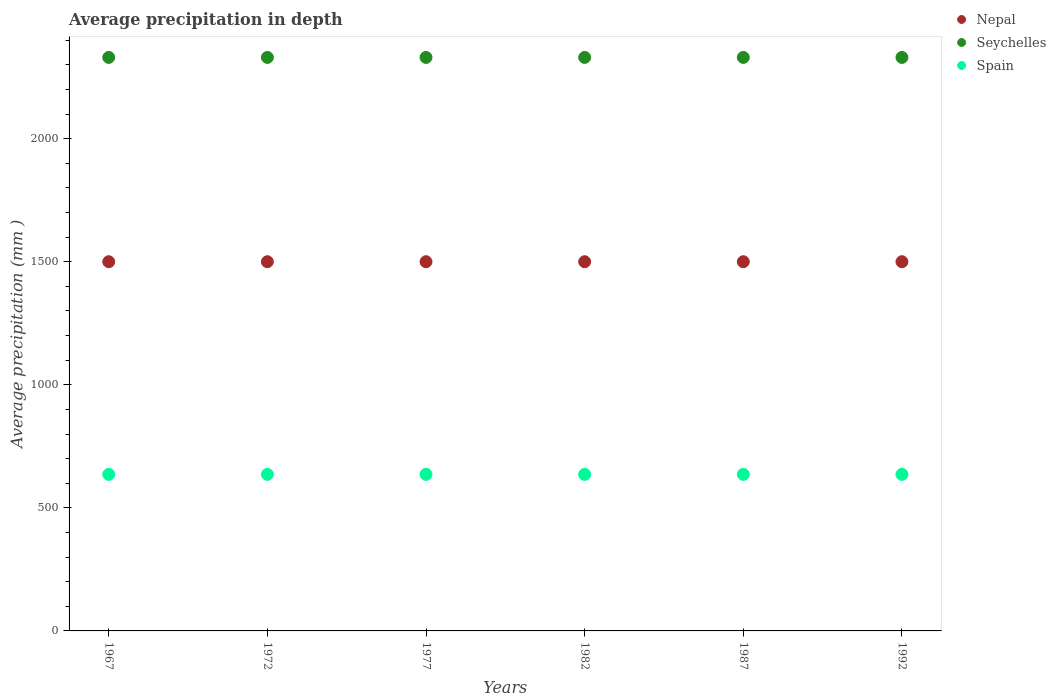How many different coloured dotlines are there?
Provide a succinct answer. 3. Is the number of dotlines equal to the number of legend labels?
Offer a very short reply. Yes. What is the average precipitation in Spain in 1972?
Make the answer very short. 636. Across all years, what is the maximum average precipitation in Spain?
Your answer should be very brief. 636. Across all years, what is the minimum average precipitation in Nepal?
Offer a terse response. 1500. In which year was the average precipitation in Spain maximum?
Make the answer very short. 1967. In which year was the average precipitation in Seychelles minimum?
Keep it short and to the point. 1967. What is the total average precipitation in Spain in the graph?
Provide a short and direct response. 3816. What is the difference between the average precipitation in Nepal in 1982 and that in 1987?
Your answer should be compact. 0. What is the difference between the average precipitation in Nepal in 1992 and the average precipitation in Seychelles in 1972?
Keep it short and to the point. -830. What is the average average precipitation in Spain per year?
Your answer should be compact. 636. In the year 1967, what is the difference between the average precipitation in Nepal and average precipitation in Spain?
Your answer should be very brief. 864. Is the average precipitation in Spain in 1967 less than that in 1992?
Your response must be concise. No. Is the difference between the average precipitation in Nepal in 1972 and 1992 greater than the difference between the average precipitation in Spain in 1972 and 1992?
Offer a terse response. No. What is the difference between the highest and the second highest average precipitation in Spain?
Offer a terse response. 0. Does the average precipitation in Seychelles monotonically increase over the years?
Provide a short and direct response. No. How many dotlines are there?
Ensure brevity in your answer.  3. What is the difference between two consecutive major ticks on the Y-axis?
Offer a very short reply. 500. Are the values on the major ticks of Y-axis written in scientific E-notation?
Your response must be concise. No. Does the graph contain any zero values?
Ensure brevity in your answer.  No. Does the graph contain grids?
Your answer should be very brief. No. Where does the legend appear in the graph?
Offer a very short reply. Top right. What is the title of the graph?
Offer a terse response. Average precipitation in depth. What is the label or title of the X-axis?
Keep it short and to the point. Years. What is the label or title of the Y-axis?
Provide a short and direct response. Average precipitation (mm ). What is the Average precipitation (mm ) of Nepal in 1967?
Offer a terse response. 1500. What is the Average precipitation (mm ) in Seychelles in 1967?
Offer a very short reply. 2330. What is the Average precipitation (mm ) of Spain in 1967?
Provide a succinct answer. 636. What is the Average precipitation (mm ) in Nepal in 1972?
Your answer should be very brief. 1500. What is the Average precipitation (mm ) of Seychelles in 1972?
Give a very brief answer. 2330. What is the Average precipitation (mm ) of Spain in 1972?
Your response must be concise. 636. What is the Average precipitation (mm ) of Nepal in 1977?
Your answer should be compact. 1500. What is the Average precipitation (mm ) of Seychelles in 1977?
Provide a short and direct response. 2330. What is the Average precipitation (mm ) of Spain in 1977?
Offer a very short reply. 636. What is the Average precipitation (mm ) in Nepal in 1982?
Offer a very short reply. 1500. What is the Average precipitation (mm ) of Seychelles in 1982?
Make the answer very short. 2330. What is the Average precipitation (mm ) in Spain in 1982?
Provide a succinct answer. 636. What is the Average precipitation (mm ) in Nepal in 1987?
Ensure brevity in your answer.  1500. What is the Average precipitation (mm ) in Seychelles in 1987?
Your answer should be compact. 2330. What is the Average precipitation (mm ) in Spain in 1987?
Ensure brevity in your answer.  636. What is the Average precipitation (mm ) of Nepal in 1992?
Provide a succinct answer. 1500. What is the Average precipitation (mm ) in Seychelles in 1992?
Provide a succinct answer. 2330. What is the Average precipitation (mm ) of Spain in 1992?
Offer a very short reply. 636. Across all years, what is the maximum Average precipitation (mm ) of Nepal?
Make the answer very short. 1500. Across all years, what is the maximum Average precipitation (mm ) in Seychelles?
Ensure brevity in your answer.  2330. Across all years, what is the maximum Average precipitation (mm ) of Spain?
Offer a terse response. 636. Across all years, what is the minimum Average precipitation (mm ) in Nepal?
Make the answer very short. 1500. Across all years, what is the minimum Average precipitation (mm ) in Seychelles?
Keep it short and to the point. 2330. Across all years, what is the minimum Average precipitation (mm ) of Spain?
Make the answer very short. 636. What is the total Average precipitation (mm ) of Nepal in the graph?
Make the answer very short. 9000. What is the total Average precipitation (mm ) in Seychelles in the graph?
Make the answer very short. 1.40e+04. What is the total Average precipitation (mm ) of Spain in the graph?
Make the answer very short. 3816. What is the difference between the Average precipitation (mm ) of Seychelles in 1967 and that in 1972?
Ensure brevity in your answer.  0. What is the difference between the Average precipitation (mm ) in Nepal in 1967 and that in 1977?
Your response must be concise. 0. What is the difference between the Average precipitation (mm ) in Nepal in 1967 and that in 1982?
Your answer should be very brief. 0. What is the difference between the Average precipitation (mm ) in Seychelles in 1967 and that in 1982?
Offer a very short reply. 0. What is the difference between the Average precipitation (mm ) in Spain in 1967 and that in 1982?
Offer a very short reply. 0. What is the difference between the Average precipitation (mm ) of Seychelles in 1967 and that in 1987?
Make the answer very short. 0. What is the difference between the Average precipitation (mm ) in Seychelles in 1967 and that in 1992?
Offer a very short reply. 0. What is the difference between the Average precipitation (mm ) in Spain in 1967 and that in 1992?
Your answer should be very brief. 0. What is the difference between the Average precipitation (mm ) of Nepal in 1972 and that in 1977?
Ensure brevity in your answer.  0. What is the difference between the Average precipitation (mm ) of Seychelles in 1972 and that in 1977?
Keep it short and to the point. 0. What is the difference between the Average precipitation (mm ) in Spain in 1972 and that in 1977?
Provide a succinct answer. 0. What is the difference between the Average precipitation (mm ) in Nepal in 1972 and that in 1982?
Offer a very short reply. 0. What is the difference between the Average precipitation (mm ) in Seychelles in 1972 and that in 1987?
Keep it short and to the point. 0. What is the difference between the Average precipitation (mm ) in Nepal in 1972 and that in 1992?
Offer a terse response. 0. What is the difference between the Average precipitation (mm ) in Seychelles in 1972 and that in 1992?
Your response must be concise. 0. What is the difference between the Average precipitation (mm ) in Nepal in 1977 and that in 1982?
Make the answer very short. 0. What is the difference between the Average precipitation (mm ) in Spain in 1977 and that in 1982?
Give a very brief answer. 0. What is the difference between the Average precipitation (mm ) of Nepal in 1977 and that in 1987?
Offer a very short reply. 0. What is the difference between the Average precipitation (mm ) in Seychelles in 1977 and that in 1987?
Your answer should be very brief. 0. What is the difference between the Average precipitation (mm ) of Spain in 1977 and that in 1987?
Offer a very short reply. 0. What is the difference between the Average precipitation (mm ) of Spain in 1977 and that in 1992?
Your response must be concise. 0. What is the difference between the Average precipitation (mm ) of Nepal in 1982 and that in 1987?
Make the answer very short. 0. What is the difference between the Average precipitation (mm ) in Seychelles in 1982 and that in 1987?
Give a very brief answer. 0. What is the difference between the Average precipitation (mm ) in Spain in 1982 and that in 1987?
Your response must be concise. 0. What is the difference between the Average precipitation (mm ) of Nepal in 1982 and that in 1992?
Your answer should be very brief. 0. What is the difference between the Average precipitation (mm ) in Seychelles in 1982 and that in 1992?
Make the answer very short. 0. What is the difference between the Average precipitation (mm ) in Spain in 1982 and that in 1992?
Your answer should be compact. 0. What is the difference between the Average precipitation (mm ) of Seychelles in 1987 and that in 1992?
Your answer should be compact. 0. What is the difference between the Average precipitation (mm ) of Spain in 1987 and that in 1992?
Provide a succinct answer. 0. What is the difference between the Average precipitation (mm ) of Nepal in 1967 and the Average precipitation (mm ) of Seychelles in 1972?
Give a very brief answer. -830. What is the difference between the Average precipitation (mm ) in Nepal in 1967 and the Average precipitation (mm ) in Spain in 1972?
Your answer should be very brief. 864. What is the difference between the Average precipitation (mm ) of Seychelles in 1967 and the Average precipitation (mm ) of Spain in 1972?
Ensure brevity in your answer.  1694. What is the difference between the Average precipitation (mm ) of Nepal in 1967 and the Average precipitation (mm ) of Seychelles in 1977?
Offer a terse response. -830. What is the difference between the Average precipitation (mm ) in Nepal in 1967 and the Average precipitation (mm ) in Spain in 1977?
Ensure brevity in your answer.  864. What is the difference between the Average precipitation (mm ) in Seychelles in 1967 and the Average precipitation (mm ) in Spain in 1977?
Ensure brevity in your answer.  1694. What is the difference between the Average precipitation (mm ) in Nepal in 1967 and the Average precipitation (mm ) in Seychelles in 1982?
Your response must be concise. -830. What is the difference between the Average precipitation (mm ) in Nepal in 1967 and the Average precipitation (mm ) in Spain in 1982?
Your response must be concise. 864. What is the difference between the Average precipitation (mm ) of Seychelles in 1967 and the Average precipitation (mm ) of Spain in 1982?
Keep it short and to the point. 1694. What is the difference between the Average precipitation (mm ) of Nepal in 1967 and the Average precipitation (mm ) of Seychelles in 1987?
Make the answer very short. -830. What is the difference between the Average precipitation (mm ) of Nepal in 1967 and the Average precipitation (mm ) of Spain in 1987?
Provide a short and direct response. 864. What is the difference between the Average precipitation (mm ) of Seychelles in 1967 and the Average precipitation (mm ) of Spain in 1987?
Offer a terse response. 1694. What is the difference between the Average precipitation (mm ) of Nepal in 1967 and the Average precipitation (mm ) of Seychelles in 1992?
Ensure brevity in your answer.  -830. What is the difference between the Average precipitation (mm ) of Nepal in 1967 and the Average precipitation (mm ) of Spain in 1992?
Your answer should be very brief. 864. What is the difference between the Average precipitation (mm ) in Seychelles in 1967 and the Average precipitation (mm ) in Spain in 1992?
Provide a succinct answer. 1694. What is the difference between the Average precipitation (mm ) in Nepal in 1972 and the Average precipitation (mm ) in Seychelles in 1977?
Keep it short and to the point. -830. What is the difference between the Average precipitation (mm ) in Nepal in 1972 and the Average precipitation (mm ) in Spain in 1977?
Give a very brief answer. 864. What is the difference between the Average precipitation (mm ) in Seychelles in 1972 and the Average precipitation (mm ) in Spain in 1977?
Your response must be concise. 1694. What is the difference between the Average precipitation (mm ) in Nepal in 1972 and the Average precipitation (mm ) in Seychelles in 1982?
Your answer should be very brief. -830. What is the difference between the Average precipitation (mm ) of Nepal in 1972 and the Average precipitation (mm ) of Spain in 1982?
Ensure brevity in your answer.  864. What is the difference between the Average precipitation (mm ) of Seychelles in 1972 and the Average precipitation (mm ) of Spain in 1982?
Your response must be concise. 1694. What is the difference between the Average precipitation (mm ) in Nepal in 1972 and the Average precipitation (mm ) in Seychelles in 1987?
Ensure brevity in your answer.  -830. What is the difference between the Average precipitation (mm ) in Nepal in 1972 and the Average precipitation (mm ) in Spain in 1987?
Your answer should be compact. 864. What is the difference between the Average precipitation (mm ) of Seychelles in 1972 and the Average precipitation (mm ) of Spain in 1987?
Your answer should be very brief. 1694. What is the difference between the Average precipitation (mm ) of Nepal in 1972 and the Average precipitation (mm ) of Seychelles in 1992?
Your answer should be compact. -830. What is the difference between the Average precipitation (mm ) of Nepal in 1972 and the Average precipitation (mm ) of Spain in 1992?
Provide a short and direct response. 864. What is the difference between the Average precipitation (mm ) in Seychelles in 1972 and the Average precipitation (mm ) in Spain in 1992?
Offer a terse response. 1694. What is the difference between the Average precipitation (mm ) of Nepal in 1977 and the Average precipitation (mm ) of Seychelles in 1982?
Ensure brevity in your answer.  -830. What is the difference between the Average precipitation (mm ) of Nepal in 1977 and the Average precipitation (mm ) of Spain in 1982?
Your answer should be very brief. 864. What is the difference between the Average precipitation (mm ) of Seychelles in 1977 and the Average precipitation (mm ) of Spain in 1982?
Provide a succinct answer. 1694. What is the difference between the Average precipitation (mm ) of Nepal in 1977 and the Average precipitation (mm ) of Seychelles in 1987?
Your answer should be very brief. -830. What is the difference between the Average precipitation (mm ) in Nepal in 1977 and the Average precipitation (mm ) in Spain in 1987?
Your answer should be very brief. 864. What is the difference between the Average precipitation (mm ) of Seychelles in 1977 and the Average precipitation (mm ) of Spain in 1987?
Make the answer very short. 1694. What is the difference between the Average precipitation (mm ) of Nepal in 1977 and the Average precipitation (mm ) of Seychelles in 1992?
Offer a very short reply. -830. What is the difference between the Average precipitation (mm ) in Nepal in 1977 and the Average precipitation (mm ) in Spain in 1992?
Ensure brevity in your answer.  864. What is the difference between the Average precipitation (mm ) in Seychelles in 1977 and the Average precipitation (mm ) in Spain in 1992?
Provide a short and direct response. 1694. What is the difference between the Average precipitation (mm ) in Nepal in 1982 and the Average precipitation (mm ) in Seychelles in 1987?
Make the answer very short. -830. What is the difference between the Average precipitation (mm ) of Nepal in 1982 and the Average precipitation (mm ) of Spain in 1987?
Give a very brief answer. 864. What is the difference between the Average precipitation (mm ) of Seychelles in 1982 and the Average precipitation (mm ) of Spain in 1987?
Offer a very short reply. 1694. What is the difference between the Average precipitation (mm ) of Nepal in 1982 and the Average precipitation (mm ) of Seychelles in 1992?
Your answer should be very brief. -830. What is the difference between the Average precipitation (mm ) of Nepal in 1982 and the Average precipitation (mm ) of Spain in 1992?
Offer a terse response. 864. What is the difference between the Average precipitation (mm ) in Seychelles in 1982 and the Average precipitation (mm ) in Spain in 1992?
Make the answer very short. 1694. What is the difference between the Average precipitation (mm ) in Nepal in 1987 and the Average precipitation (mm ) in Seychelles in 1992?
Offer a very short reply. -830. What is the difference between the Average precipitation (mm ) in Nepal in 1987 and the Average precipitation (mm ) in Spain in 1992?
Provide a short and direct response. 864. What is the difference between the Average precipitation (mm ) in Seychelles in 1987 and the Average precipitation (mm ) in Spain in 1992?
Provide a short and direct response. 1694. What is the average Average precipitation (mm ) in Nepal per year?
Your answer should be very brief. 1500. What is the average Average precipitation (mm ) of Seychelles per year?
Give a very brief answer. 2330. What is the average Average precipitation (mm ) in Spain per year?
Offer a very short reply. 636. In the year 1967, what is the difference between the Average precipitation (mm ) in Nepal and Average precipitation (mm ) in Seychelles?
Offer a terse response. -830. In the year 1967, what is the difference between the Average precipitation (mm ) in Nepal and Average precipitation (mm ) in Spain?
Your answer should be compact. 864. In the year 1967, what is the difference between the Average precipitation (mm ) of Seychelles and Average precipitation (mm ) of Spain?
Keep it short and to the point. 1694. In the year 1972, what is the difference between the Average precipitation (mm ) of Nepal and Average precipitation (mm ) of Seychelles?
Give a very brief answer. -830. In the year 1972, what is the difference between the Average precipitation (mm ) of Nepal and Average precipitation (mm ) of Spain?
Your answer should be compact. 864. In the year 1972, what is the difference between the Average precipitation (mm ) in Seychelles and Average precipitation (mm ) in Spain?
Keep it short and to the point. 1694. In the year 1977, what is the difference between the Average precipitation (mm ) of Nepal and Average precipitation (mm ) of Seychelles?
Provide a succinct answer. -830. In the year 1977, what is the difference between the Average precipitation (mm ) of Nepal and Average precipitation (mm ) of Spain?
Give a very brief answer. 864. In the year 1977, what is the difference between the Average precipitation (mm ) in Seychelles and Average precipitation (mm ) in Spain?
Keep it short and to the point. 1694. In the year 1982, what is the difference between the Average precipitation (mm ) of Nepal and Average precipitation (mm ) of Seychelles?
Make the answer very short. -830. In the year 1982, what is the difference between the Average precipitation (mm ) of Nepal and Average precipitation (mm ) of Spain?
Make the answer very short. 864. In the year 1982, what is the difference between the Average precipitation (mm ) of Seychelles and Average precipitation (mm ) of Spain?
Provide a succinct answer. 1694. In the year 1987, what is the difference between the Average precipitation (mm ) of Nepal and Average precipitation (mm ) of Seychelles?
Offer a very short reply. -830. In the year 1987, what is the difference between the Average precipitation (mm ) of Nepal and Average precipitation (mm ) of Spain?
Your answer should be compact. 864. In the year 1987, what is the difference between the Average precipitation (mm ) in Seychelles and Average precipitation (mm ) in Spain?
Make the answer very short. 1694. In the year 1992, what is the difference between the Average precipitation (mm ) in Nepal and Average precipitation (mm ) in Seychelles?
Provide a short and direct response. -830. In the year 1992, what is the difference between the Average precipitation (mm ) in Nepal and Average precipitation (mm ) in Spain?
Provide a short and direct response. 864. In the year 1992, what is the difference between the Average precipitation (mm ) in Seychelles and Average precipitation (mm ) in Spain?
Your answer should be compact. 1694. What is the ratio of the Average precipitation (mm ) in Seychelles in 1967 to that in 1972?
Your answer should be very brief. 1. What is the ratio of the Average precipitation (mm ) in Spain in 1967 to that in 1972?
Your answer should be compact. 1. What is the ratio of the Average precipitation (mm ) of Seychelles in 1967 to that in 1982?
Your answer should be very brief. 1. What is the ratio of the Average precipitation (mm ) of Spain in 1967 to that in 1982?
Your answer should be compact. 1. What is the ratio of the Average precipitation (mm ) of Spain in 1967 to that in 1987?
Your response must be concise. 1. What is the ratio of the Average precipitation (mm ) of Seychelles in 1967 to that in 1992?
Provide a succinct answer. 1. What is the ratio of the Average precipitation (mm ) of Spain in 1967 to that in 1992?
Offer a very short reply. 1. What is the ratio of the Average precipitation (mm ) of Seychelles in 1972 to that in 1977?
Ensure brevity in your answer.  1. What is the ratio of the Average precipitation (mm ) of Nepal in 1972 to that in 1982?
Keep it short and to the point. 1. What is the ratio of the Average precipitation (mm ) of Seychelles in 1972 to that in 1982?
Your answer should be compact. 1. What is the ratio of the Average precipitation (mm ) of Spain in 1972 to that in 1982?
Make the answer very short. 1. What is the ratio of the Average precipitation (mm ) in Spain in 1972 to that in 1992?
Your answer should be very brief. 1. What is the ratio of the Average precipitation (mm ) of Nepal in 1977 to that in 1982?
Provide a short and direct response. 1. What is the ratio of the Average precipitation (mm ) of Nepal in 1977 to that in 1987?
Make the answer very short. 1. What is the ratio of the Average precipitation (mm ) of Spain in 1977 to that in 1987?
Your answer should be compact. 1. What is the ratio of the Average precipitation (mm ) of Seychelles in 1977 to that in 1992?
Keep it short and to the point. 1. What is the ratio of the Average precipitation (mm ) in Nepal in 1982 to that in 1987?
Keep it short and to the point. 1. What is the ratio of the Average precipitation (mm ) in Spain in 1982 to that in 1992?
Give a very brief answer. 1. What is the ratio of the Average precipitation (mm ) of Nepal in 1987 to that in 1992?
Ensure brevity in your answer.  1. What is the ratio of the Average precipitation (mm ) of Spain in 1987 to that in 1992?
Provide a succinct answer. 1. What is the difference between the highest and the second highest Average precipitation (mm ) in Nepal?
Provide a succinct answer. 0. What is the difference between the highest and the second highest Average precipitation (mm ) of Spain?
Your answer should be very brief. 0. What is the difference between the highest and the lowest Average precipitation (mm ) of Nepal?
Make the answer very short. 0. What is the difference between the highest and the lowest Average precipitation (mm ) in Spain?
Keep it short and to the point. 0. 